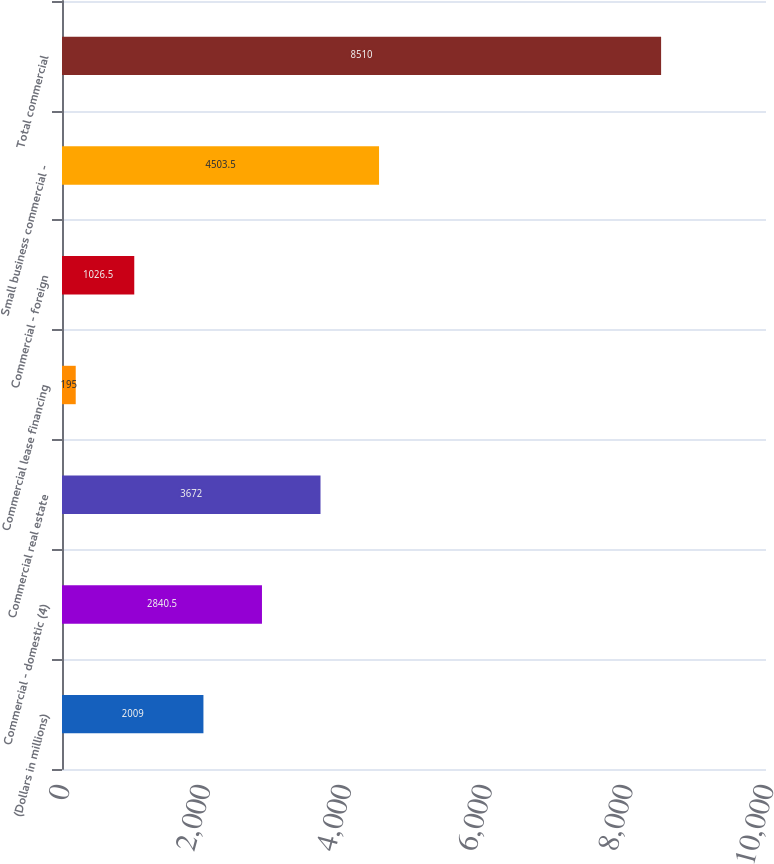Convert chart to OTSL. <chart><loc_0><loc_0><loc_500><loc_500><bar_chart><fcel>(Dollars in millions)<fcel>Commercial - domestic (4)<fcel>Commercial real estate<fcel>Commercial lease financing<fcel>Commercial - foreign<fcel>Small business commercial -<fcel>Total commercial<nl><fcel>2009<fcel>2840.5<fcel>3672<fcel>195<fcel>1026.5<fcel>4503.5<fcel>8510<nl></chart> 